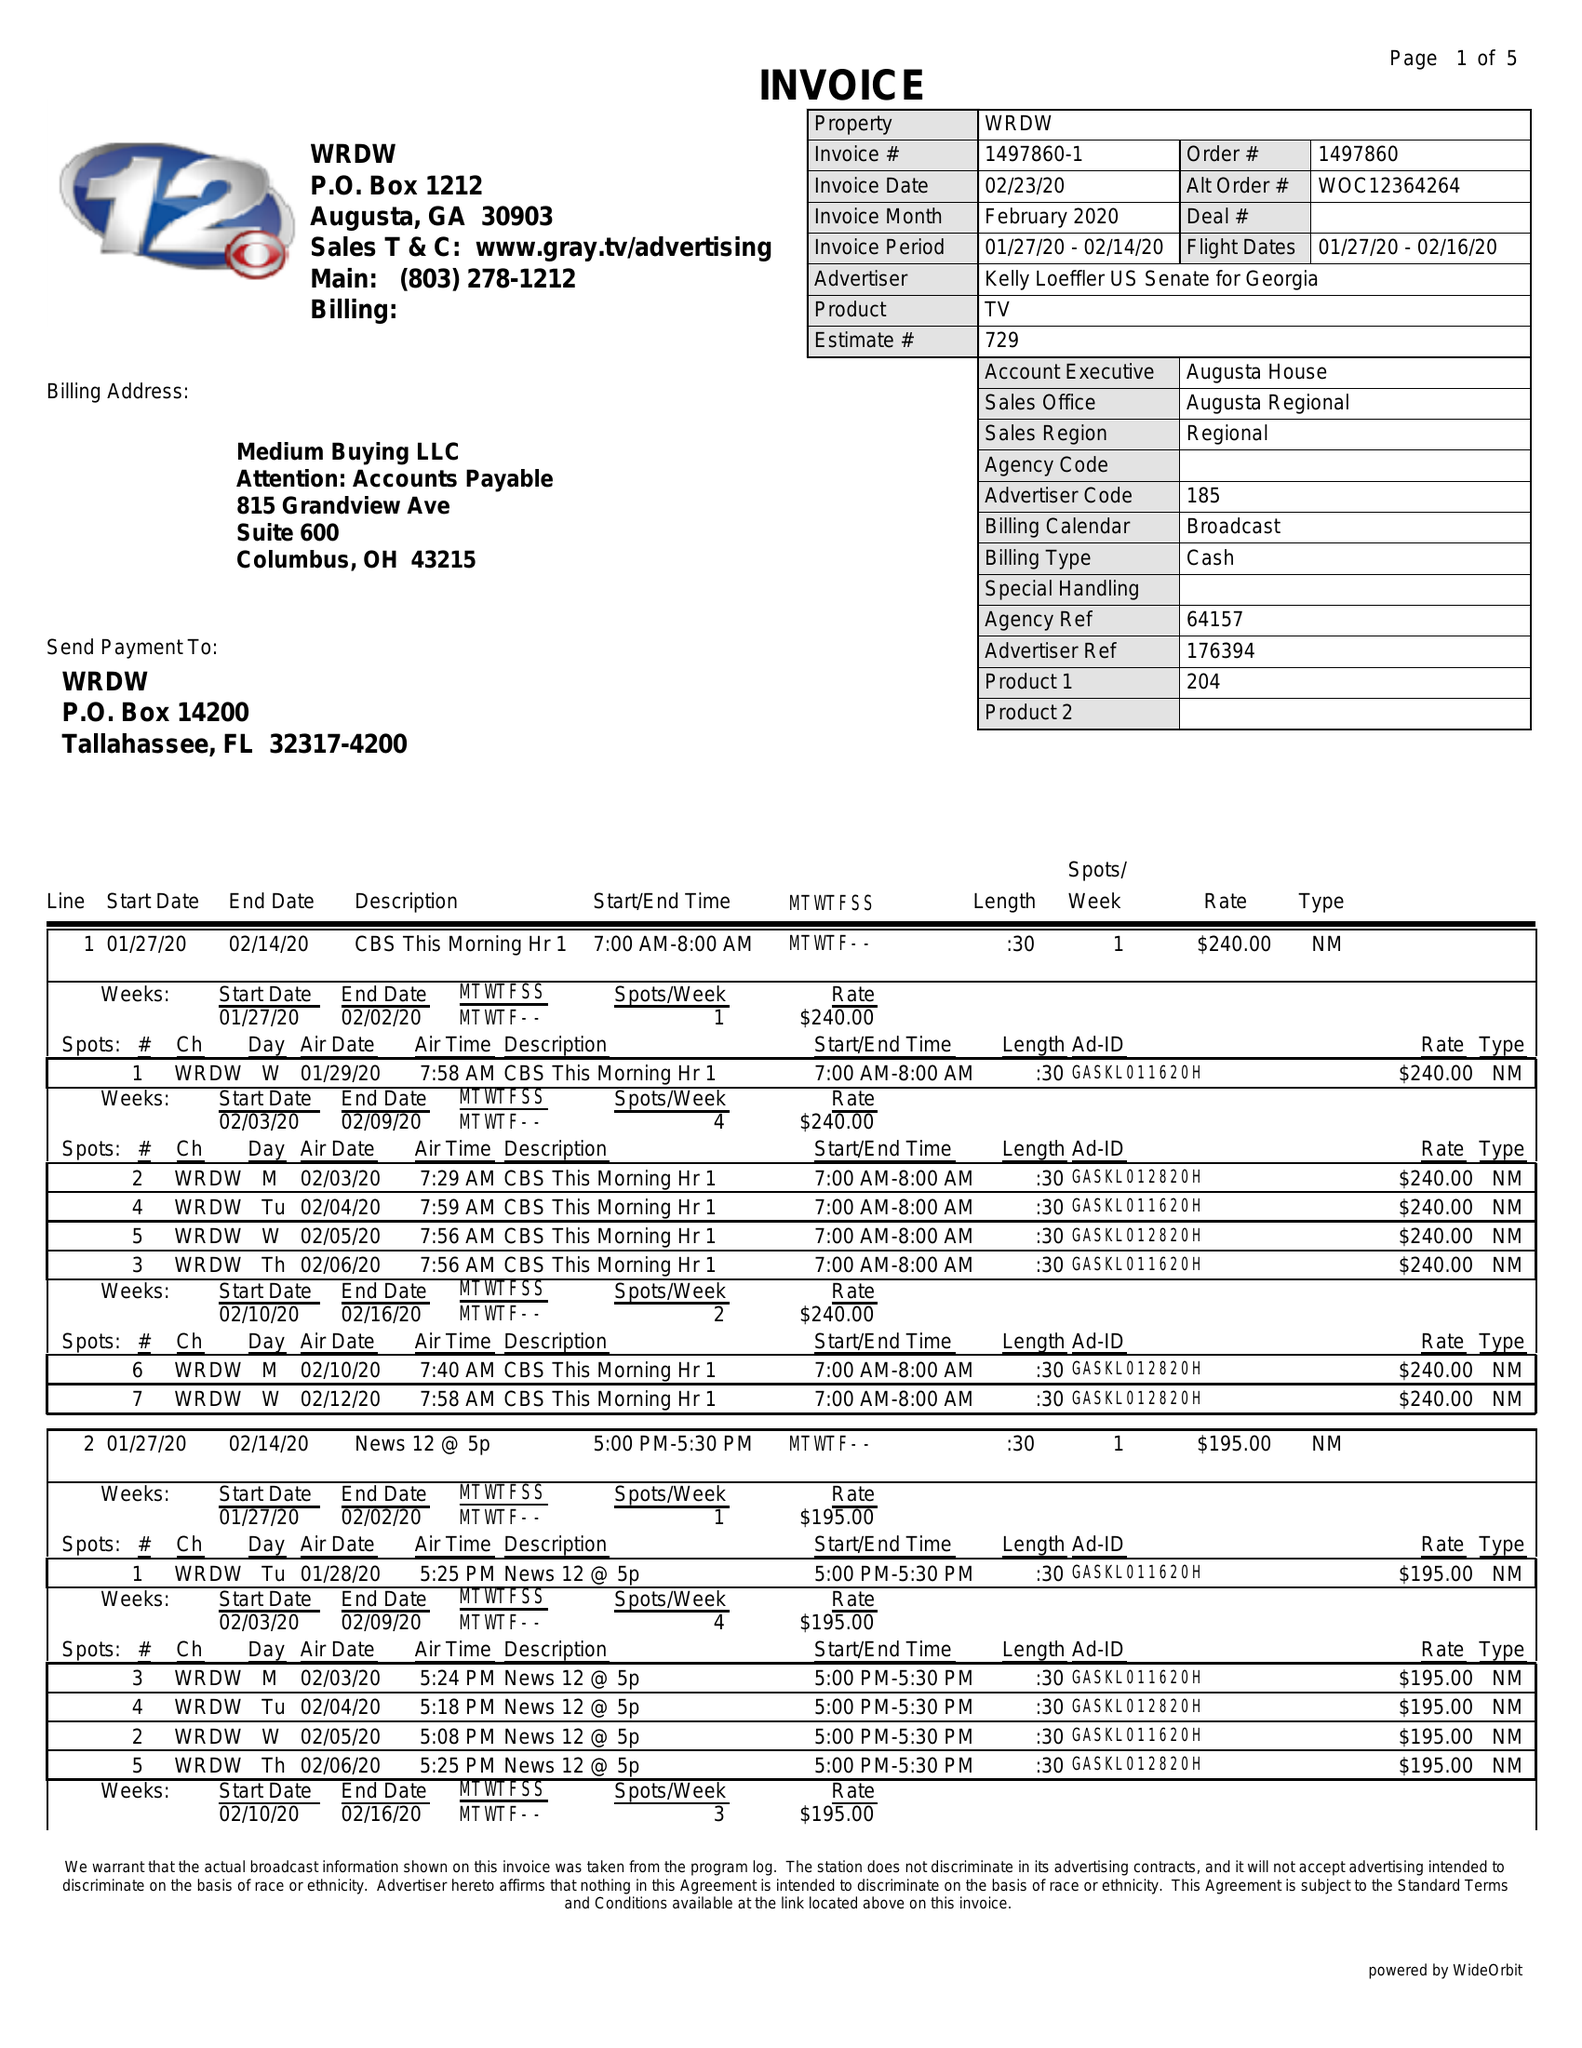What is the value for the gross_amount?
Answer the question using a single word or phrase. 23815.00 